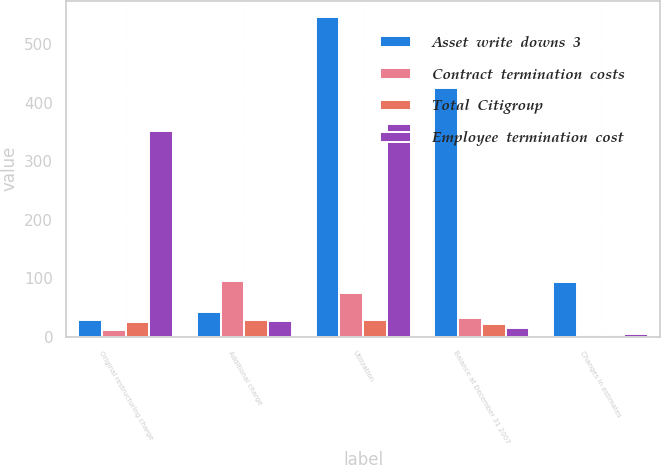<chart> <loc_0><loc_0><loc_500><loc_500><stacked_bar_chart><ecel><fcel>Original restructuring charge<fcel>Additional charge<fcel>Utilization<fcel>Balance at December 31 2007<fcel>Changes in estimates<nl><fcel>Asset  write  downs  3<fcel>29<fcel>42<fcel>547<fcel>425<fcel>93<nl><fcel>Contract  termination  costs<fcel>11<fcel>96<fcel>75<fcel>32<fcel>2<nl><fcel>Total  Citigroup<fcel>25<fcel>29<fcel>28<fcel>22<fcel>2<nl><fcel>Employee  termination  cost<fcel>352<fcel>27<fcel>363<fcel>15<fcel>4<nl></chart> 